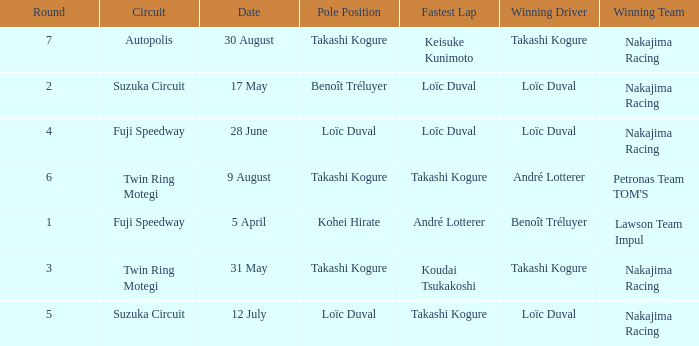How many drivers drove on Suzuka Circuit where Loïc Duval took pole position? 1.0. 